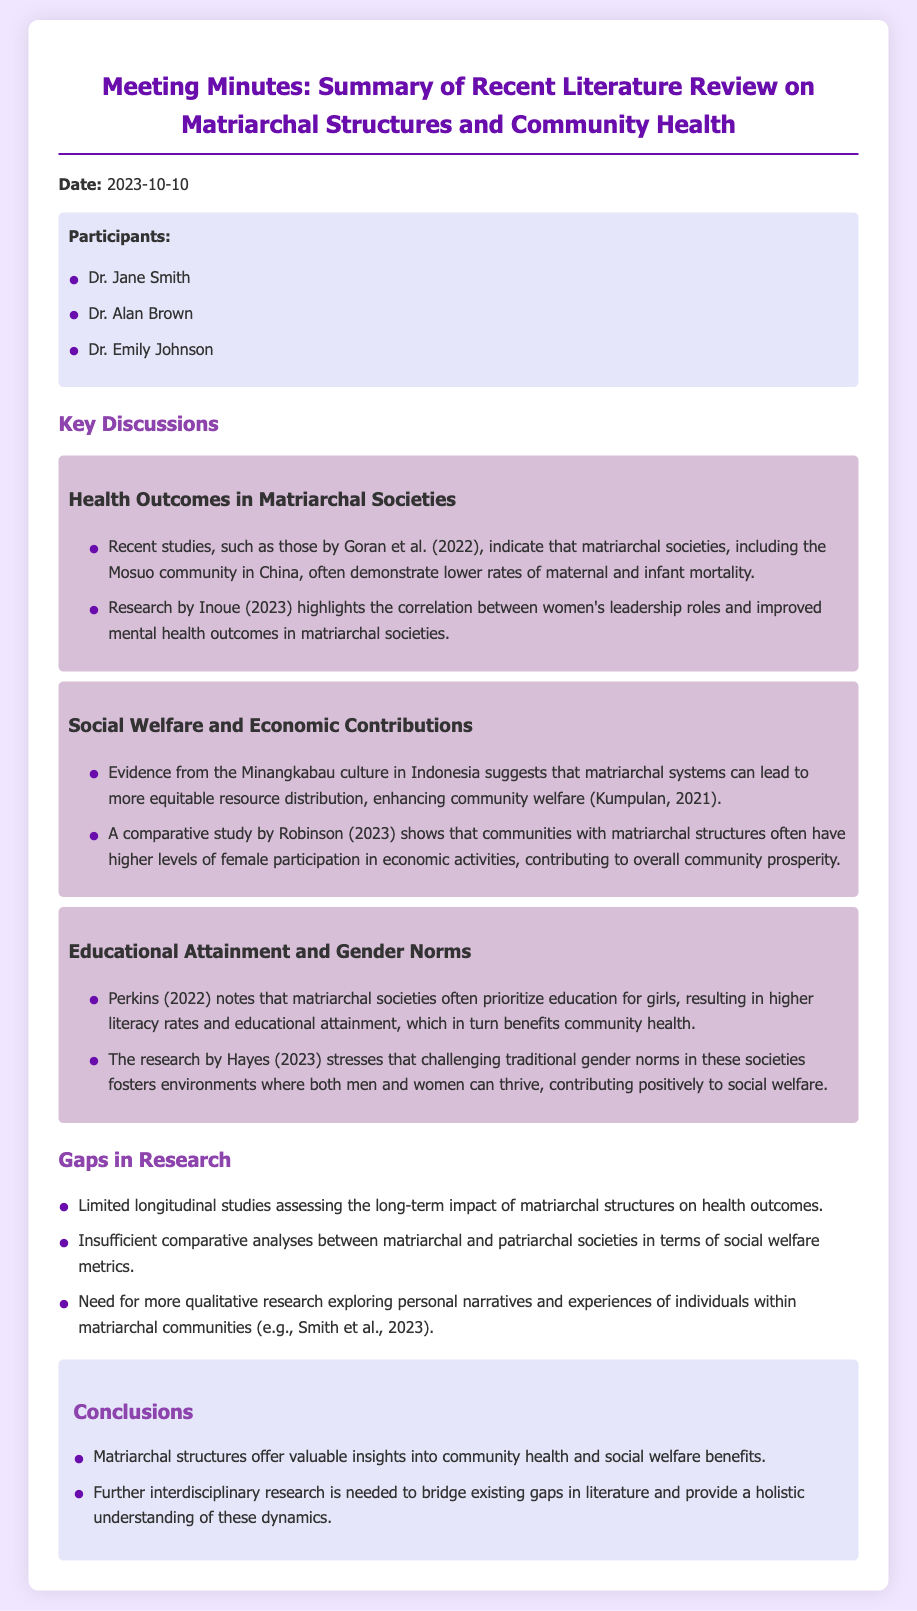What is the date of the meeting? The date of the meeting is clearly stated in the document as 2023-10-10.
Answer: 2023-10-10 Who conducted a study indicating lower rates of maternal and infant mortality in matriarchal societies? The study is cited as being conducted by Goran et al. in 2022, which discusses maternal and infant mortality rates.
Answer: Goran et al What culture is highlighted for equitable resource distribution in matriarchal systems? The Minangkabau culture in Indonesia is mentioned for equitable resource distribution enhancements in community welfare.
Answer: Minangkabau culture Which aspect of community welfare is improved by women's leadership roles according to Inoue? The document mentions improved mental health outcomes as a result of women's leadership roles in matriarchal societies according to Inoue's research.
Answer: Mental health outcomes What is a noted gap in the existing research? The document mentions a gap of limited longitudinal studies assessing the long-term impact of matriarchal structures on health outcomes.
Answer: Limited longitudinal studies What type of research is called for to explore personal narratives within matriarchal communities? The document specifies a need for more qualitative research exploring personal narratives and experiences of individuals within matriarchal communities.
Answer: Qualitative research Which theme discusses educational attainment in matriarchal societies? The theme that discusses educational attainment is titled "Educational Attainment and Gender Norms."
Answer: Educational Attainment and Gender Norms How many participants were present at the meeting? The number of participants is listed in the document; three participants attended the meeting.
Answer: Three participants 